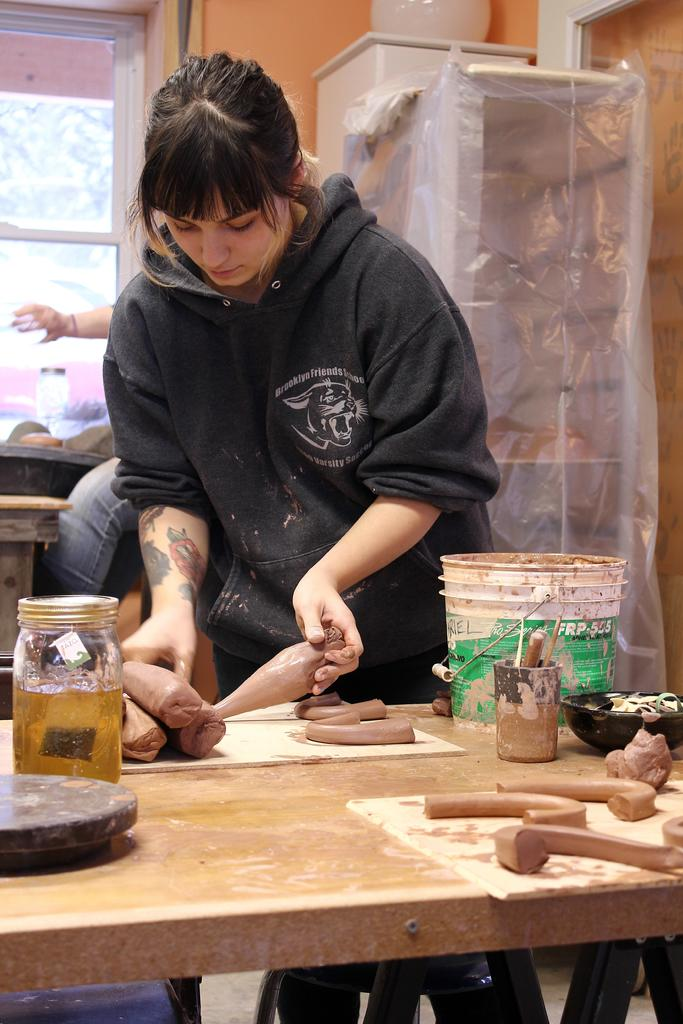What objects are on the table in the image? There is a bottle and a bucket on the table in the image. Who is present in the image? A woman is standing near the table in the image. What can be seen in the background of the image? There is a window in the background of the image. How many ants are crawling on the cabbage in the image? There is no cabbage or ants present in the image. What type of bulb is illuminating the room in the image? There is no bulb visible in the image, and the room's lighting is not mentioned in the provided facts. 